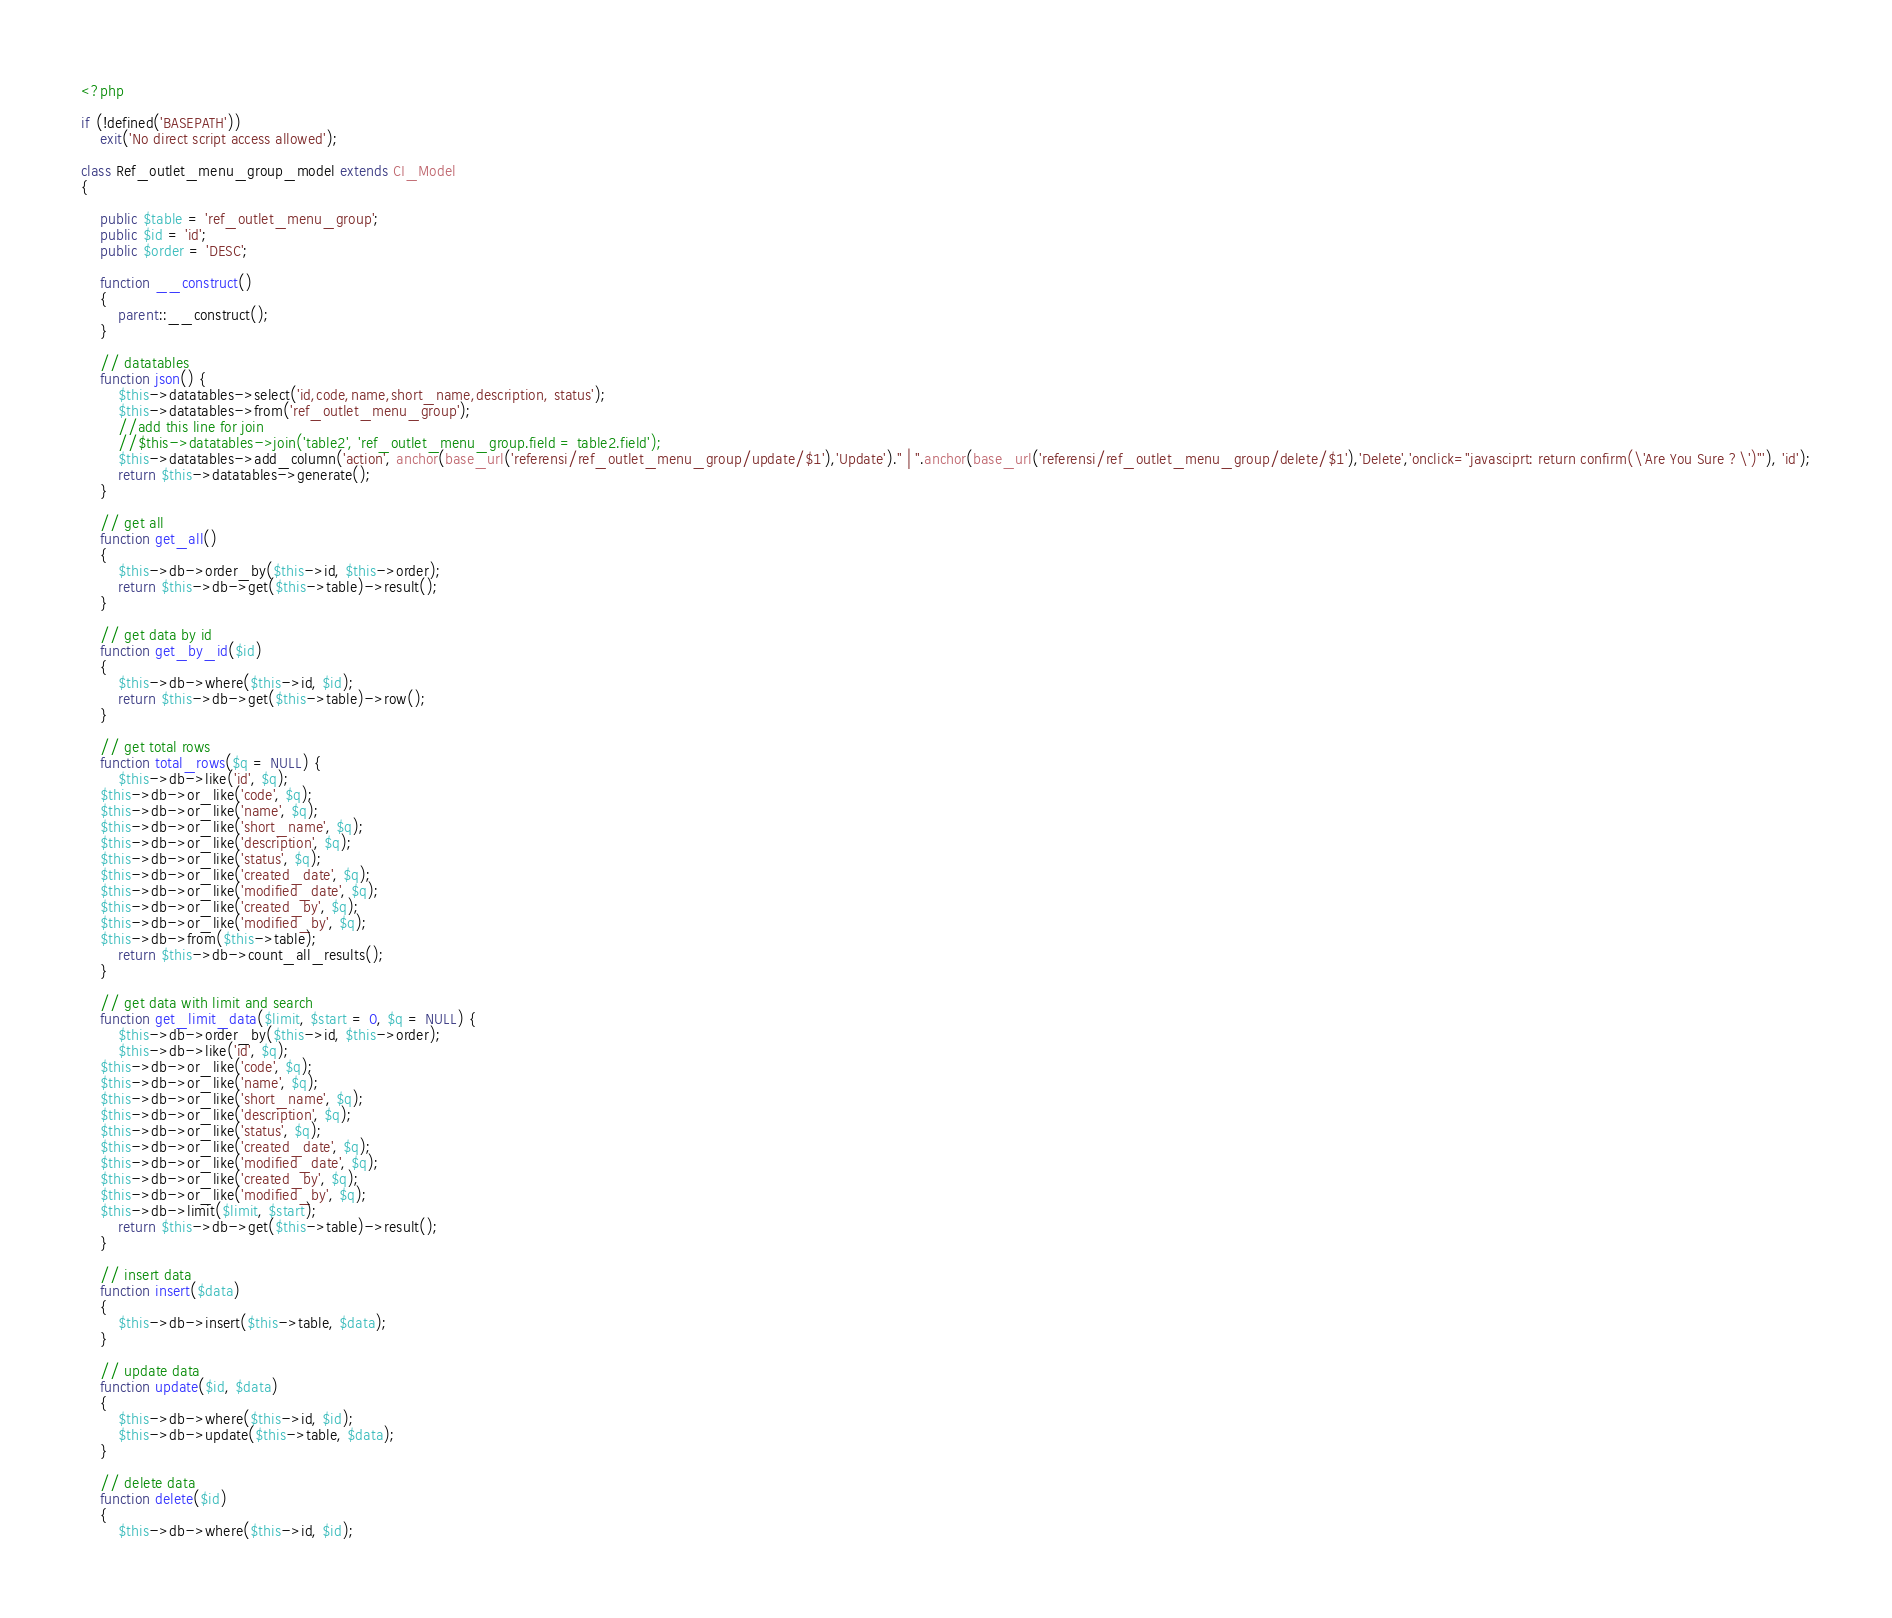Convert code to text. <code><loc_0><loc_0><loc_500><loc_500><_PHP_><?php

if (!defined('BASEPATH'))
    exit('No direct script access allowed');

class Ref_outlet_menu_group_model extends CI_Model
{

    public $table = 'ref_outlet_menu_group';
    public $id = 'id';
    public $order = 'DESC';

    function __construct()
    {
        parent::__construct();
    }

    // datatables
    function json() {
        $this->datatables->select('id,code,name,short_name,description, status');
        $this->datatables->from('ref_outlet_menu_group');
        //add this line for join
        //$this->datatables->join('table2', 'ref_outlet_menu_group.field = table2.field');
        $this->datatables->add_column('action', anchor(base_url('referensi/ref_outlet_menu_group/update/$1'),'Update')." | ".anchor(base_url('referensi/ref_outlet_menu_group/delete/$1'),'Delete','onclick="javasciprt: return confirm(\'Are You Sure ?\')"'), 'id');
        return $this->datatables->generate();
    }

    // get all
    function get_all()
    {
        $this->db->order_by($this->id, $this->order);
        return $this->db->get($this->table)->result();
    }

    // get data by id
    function get_by_id($id)
    {
        $this->db->where($this->id, $id);
        return $this->db->get($this->table)->row();
    }
    
    // get total rows
    function total_rows($q = NULL) {
        $this->db->like('id', $q);
	$this->db->or_like('code', $q);
	$this->db->or_like('name', $q);
	$this->db->or_like('short_name', $q);
	$this->db->or_like('description', $q);
	$this->db->or_like('status', $q);
	$this->db->or_like('created_date', $q);
	$this->db->or_like('modified_date', $q);
	$this->db->or_like('created_by', $q);
	$this->db->or_like('modified_by', $q);
	$this->db->from($this->table);
        return $this->db->count_all_results();
    }

    // get data with limit and search
    function get_limit_data($limit, $start = 0, $q = NULL) {
        $this->db->order_by($this->id, $this->order);
        $this->db->like('id', $q);
	$this->db->or_like('code', $q);
	$this->db->or_like('name', $q);
	$this->db->or_like('short_name', $q);
	$this->db->or_like('description', $q);
	$this->db->or_like('status', $q);
	$this->db->or_like('created_date', $q);
	$this->db->or_like('modified_date', $q);
	$this->db->or_like('created_by', $q);
	$this->db->or_like('modified_by', $q);
	$this->db->limit($limit, $start);
        return $this->db->get($this->table)->result();
    }

    // insert data
    function insert($data)
    {
        $this->db->insert($this->table, $data);
    }

    // update data
    function update($id, $data)
    {
        $this->db->where($this->id, $id);
        $this->db->update($this->table, $data);
    }

    // delete data
    function delete($id)
    {
        $this->db->where($this->id, $id);</code> 